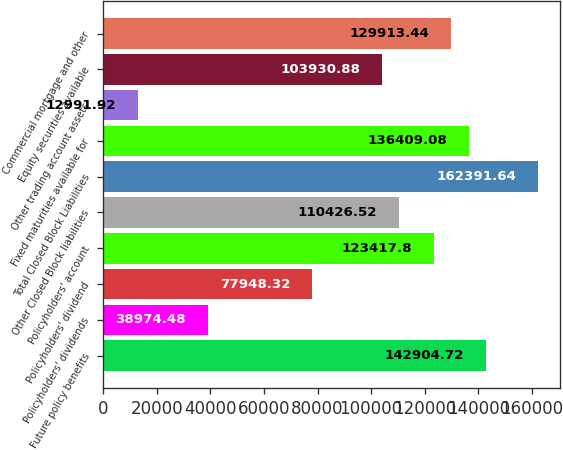<chart> <loc_0><loc_0><loc_500><loc_500><bar_chart><fcel>Future policy benefits<fcel>Policyholders' dividends<fcel>Policyholders' dividend<fcel>Policyholders' account<fcel>Other Closed Block liabilities<fcel>Total Closed Block Liabilities<fcel>Fixed maturities available for<fcel>Other trading account assets<fcel>Equity securities available<fcel>Commercial mortgage and other<nl><fcel>142905<fcel>38974.5<fcel>77948.3<fcel>123418<fcel>110427<fcel>162392<fcel>136409<fcel>12991.9<fcel>103931<fcel>129913<nl></chart> 